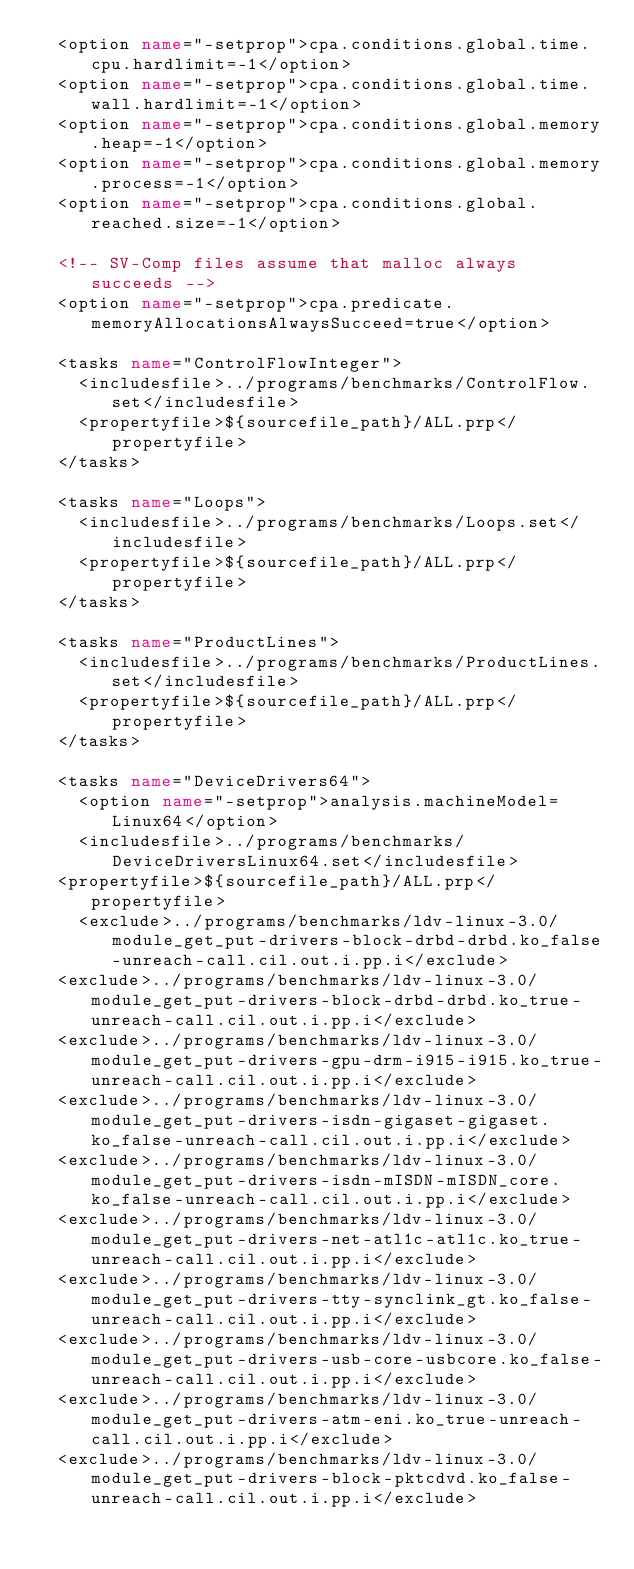Convert code to text. <code><loc_0><loc_0><loc_500><loc_500><_XML_>  <option name="-setprop">cpa.conditions.global.time.cpu.hardlimit=-1</option>
  <option name="-setprop">cpa.conditions.global.time.wall.hardlimit=-1</option>
  <option name="-setprop">cpa.conditions.global.memory.heap=-1</option>
  <option name="-setprop">cpa.conditions.global.memory.process=-1</option>
  <option name="-setprop">cpa.conditions.global.reached.size=-1</option>

  <!-- SV-Comp files assume that malloc always succeeds -->
  <option name="-setprop">cpa.predicate.memoryAllocationsAlwaysSucceed=true</option>

  <tasks name="ControlFlowInteger">
  	<includesfile>../programs/benchmarks/ControlFlow.set</includesfile>
  	<propertyfile>${sourcefile_path}/ALL.prp</propertyfile>
  </tasks>

  <tasks name="Loops">
  	<includesfile>../programs/benchmarks/Loops.set</includesfile>
  	<propertyfile>${sourcefile_path}/ALL.prp</propertyfile>
  </tasks>

  <tasks name="ProductLines">
  	<includesfile>../programs/benchmarks/ProductLines.set</includesfile>
  	<propertyfile>${sourcefile_path}/ALL.prp</propertyfile>
  </tasks>

  <tasks name="DeviceDrivers64">
  	<option name="-setprop">analysis.machineModel=Linux64</option>
    <includesfile>../programs/benchmarks/DeviceDriversLinux64.set</includesfile>
	<propertyfile>${sourcefile_path}/ALL.prp</propertyfile>
  	<exclude>../programs/benchmarks/ldv-linux-3.0/module_get_put-drivers-block-drbd-drbd.ko_false-unreach-call.cil.out.i.pp.i</exclude>
	<exclude>../programs/benchmarks/ldv-linux-3.0/module_get_put-drivers-block-drbd-drbd.ko_true-unreach-call.cil.out.i.pp.i</exclude>
	<exclude>../programs/benchmarks/ldv-linux-3.0/module_get_put-drivers-gpu-drm-i915-i915.ko_true-unreach-call.cil.out.i.pp.i</exclude>
	<exclude>../programs/benchmarks/ldv-linux-3.0/module_get_put-drivers-isdn-gigaset-gigaset.ko_false-unreach-call.cil.out.i.pp.i</exclude>
	<exclude>../programs/benchmarks/ldv-linux-3.0/module_get_put-drivers-isdn-mISDN-mISDN_core.ko_false-unreach-call.cil.out.i.pp.i</exclude>
	<exclude>../programs/benchmarks/ldv-linux-3.0/module_get_put-drivers-net-atl1c-atl1c.ko_true-unreach-call.cil.out.i.pp.i</exclude>
	<exclude>../programs/benchmarks/ldv-linux-3.0/module_get_put-drivers-tty-synclink_gt.ko_false-unreach-call.cil.out.i.pp.i</exclude>
	<exclude>../programs/benchmarks/ldv-linux-3.0/module_get_put-drivers-usb-core-usbcore.ko_false-unreach-call.cil.out.i.pp.i</exclude>
	<exclude>../programs/benchmarks/ldv-linux-3.0/module_get_put-drivers-atm-eni.ko_true-unreach-call.cil.out.i.pp.i</exclude>
	<exclude>../programs/benchmarks/ldv-linux-3.0/module_get_put-drivers-block-pktcdvd.ko_false-unreach-call.cil.out.i.pp.i</exclude></code> 